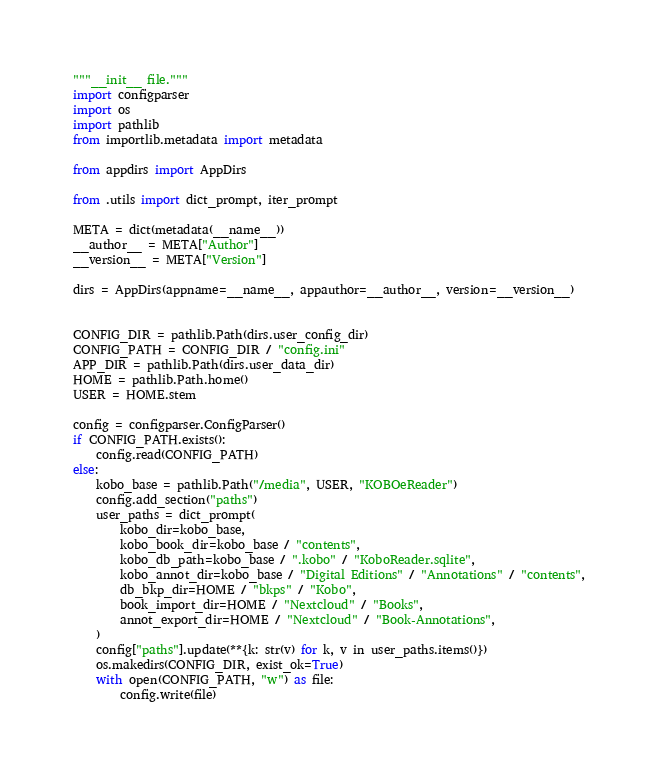Convert code to text. <code><loc_0><loc_0><loc_500><loc_500><_Python_>"""__init__ file."""
import configparser
import os
import pathlib
from importlib.metadata import metadata

from appdirs import AppDirs

from .utils import dict_prompt, iter_prompt

META = dict(metadata(__name__))
__author__ = META["Author"]
__version__ = META["Version"]

dirs = AppDirs(appname=__name__, appauthor=__author__, version=__version__)


CONFIG_DIR = pathlib.Path(dirs.user_config_dir)
CONFIG_PATH = CONFIG_DIR / "config.ini"
APP_DIR = pathlib.Path(dirs.user_data_dir)
HOME = pathlib.Path.home()
USER = HOME.stem

config = configparser.ConfigParser()
if CONFIG_PATH.exists():
    config.read(CONFIG_PATH)
else:
    kobo_base = pathlib.Path("/media", USER, "KOBOeReader")
    config.add_section("paths")
    user_paths = dict_prompt(
        kobo_dir=kobo_base,
        kobo_book_dir=kobo_base / "contents",
        kobo_db_path=kobo_base / ".kobo" / "KoboReader.sqlite",
        kobo_annot_dir=kobo_base / "Digital Editions" / "Annotations" / "contents",
        db_bkp_dir=HOME / "bkps" / "Kobo",
        book_import_dir=HOME / "Nextcloud" / "Books",
        annot_export_dir=HOME / "Nextcloud" / "Book-Annotations",
    )
    config["paths"].update(**{k: str(v) for k, v in user_paths.items()})
    os.makedirs(CONFIG_DIR, exist_ok=True)
    with open(CONFIG_PATH, "w") as file:
        config.write(file)
</code> 